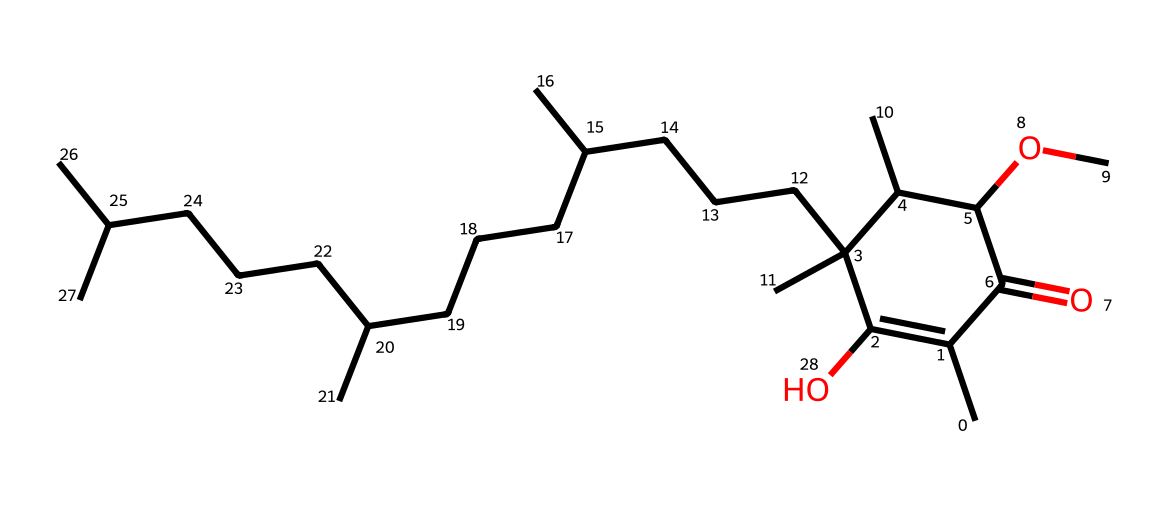What is the name of this vitamin? The structure corresponds to Tocopherol, commonly known as vitamin E. This can often be identified by the complex ring structure and the side chain typical of vitamin E species.
Answer: vitamin E How many oxygen atoms are present in the chemical structure? By analyzing the SMILES representation, there are two oxygen atoms present, one that is part of the carbonyl group (C=O) and another within the methoxy group (OC).
Answer: two What does the complex ring structure indicate about the properties of this vitamin? The presence of the multicyclic structure typically indicates a higher degree of stability and lipophilicity, which is characteristic of fat-soluble vitamins, like vitamin E. The rings provide a rigid structure that may contribute to its antioxidant properties.
Answer: stability How many carbon atoms are in the molecule? Counting the carbon atoms represented in the SMILES structure reveals a total of 29 carbon atoms. Each carbon character in the structure contributes to the total count.
Answer: 29 What type of chemical bonding is predominant in this vitamin? Analyzing the structure shows that non-polar covalent bonds are predominant due to the large number of carbon and hydrogen atoms, with limited polar characteristics from the functional groups present.
Answer: non-polar covalent bonds Why is the branched structure significant for vitamin E? The branched structure allows vitamin E to be hydrophobic, contributing to its function as an antioxidant by integrating into cell membranes where it protects against oxidative damage, which is akin to how NLP models integrate diverse data points for better understanding.
Answer: hydrophobic What is the simplest functional group in this vitamin? In the structure, the hydroxyl group (-OH) is the simplest and key functional group that contributes to its biochemical activity, particularly its role in antioxidant activity.
Answer: hydroxyl group 